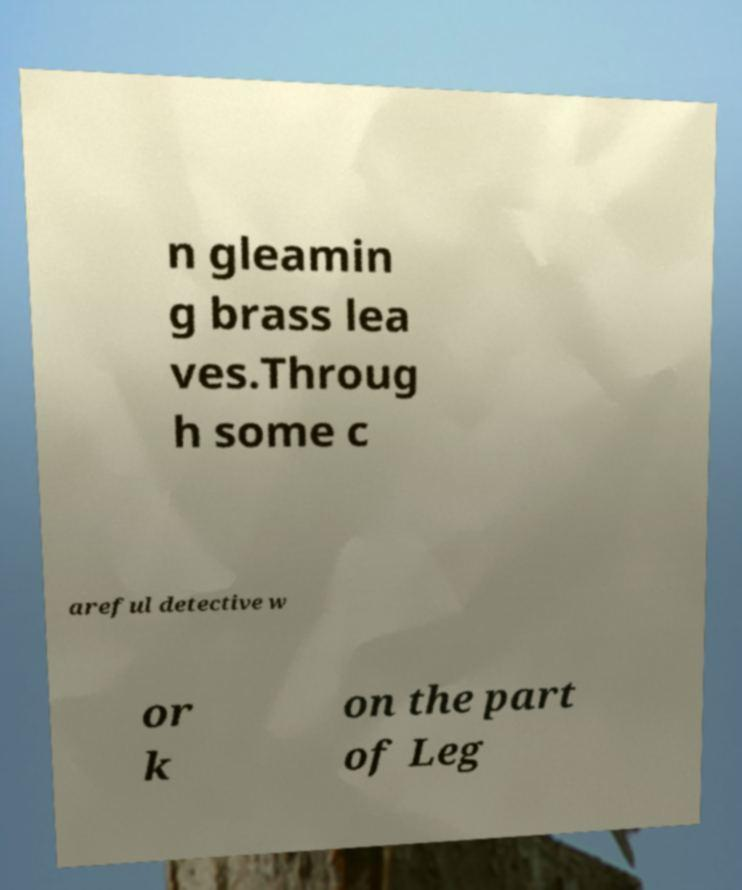I need the written content from this picture converted into text. Can you do that? n gleamin g brass lea ves.Throug h some c areful detective w or k on the part of Leg 